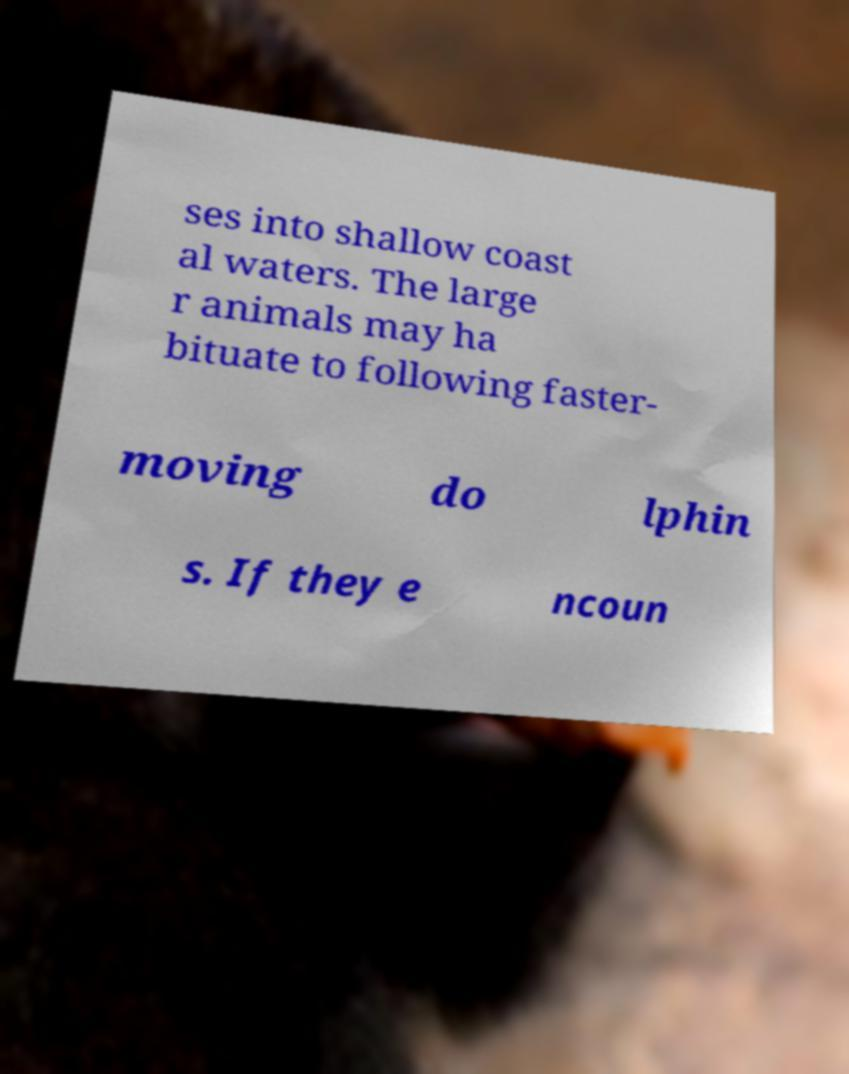For documentation purposes, I need the text within this image transcribed. Could you provide that? ses into shallow coast al waters. The large r animals may ha bituate to following faster- moving do lphin s. If they e ncoun 